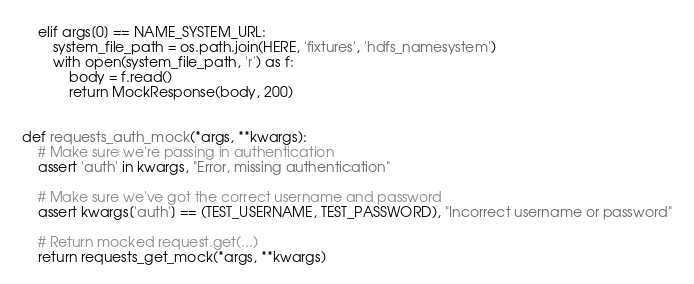<code> <loc_0><loc_0><loc_500><loc_500><_Python_>    elif args[0] == NAME_SYSTEM_URL:
        system_file_path = os.path.join(HERE, 'fixtures', 'hdfs_namesystem')
        with open(system_file_path, 'r') as f:
            body = f.read()
            return MockResponse(body, 200)


def requests_auth_mock(*args, **kwargs):
    # Make sure we're passing in authentication
    assert 'auth' in kwargs, "Error, missing authentication"

    # Make sure we've got the correct username and password
    assert kwargs['auth'] == (TEST_USERNAME, TEST_PASSWORD), "Incorrect username or password"

    # Return mocked request.get(...)
    return requests_get_mock(*args, **kwargs)
</code> 